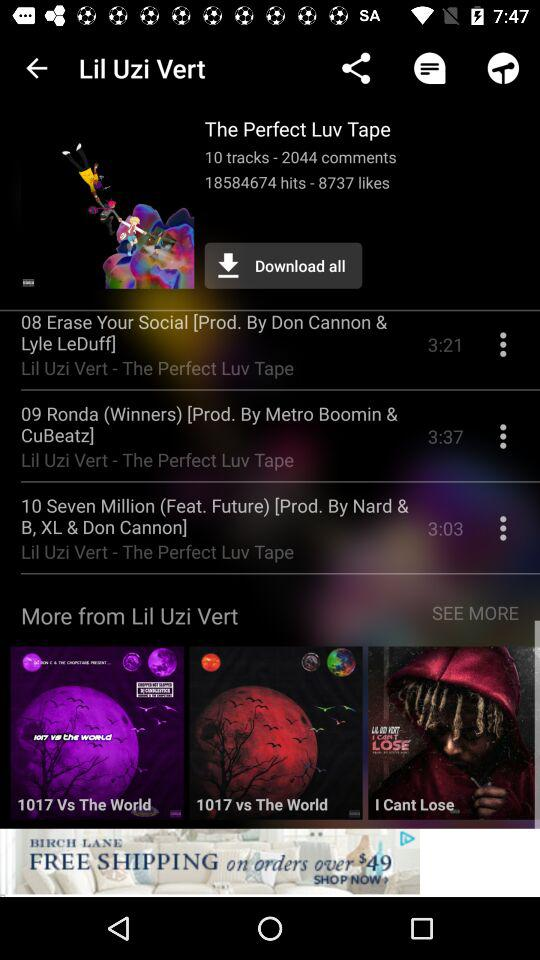How many tracks are there on the album?
Answer the question using a single word or phrase. 10 